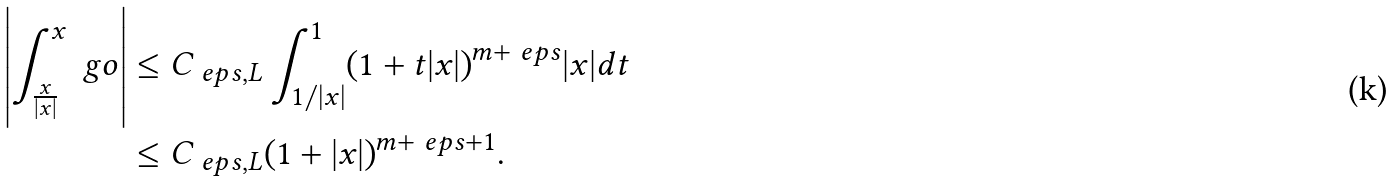<formula> <loc_0><loc_0><loc_500><loc_500>\left | \int _ { \frac { x } { | x | } } ^ { x } \ g o \right | & \leq C _ { \ e p s , L } \int _ { 1 / | x | } ^ { 1 } ( 1 + t | x | ) ^ { m + \ e p s } | x | d t \\ & \leq C _ { \ e p s , L } ( 1 + | x | ) ^ { m + \ e p s + 1 } .</formula> 